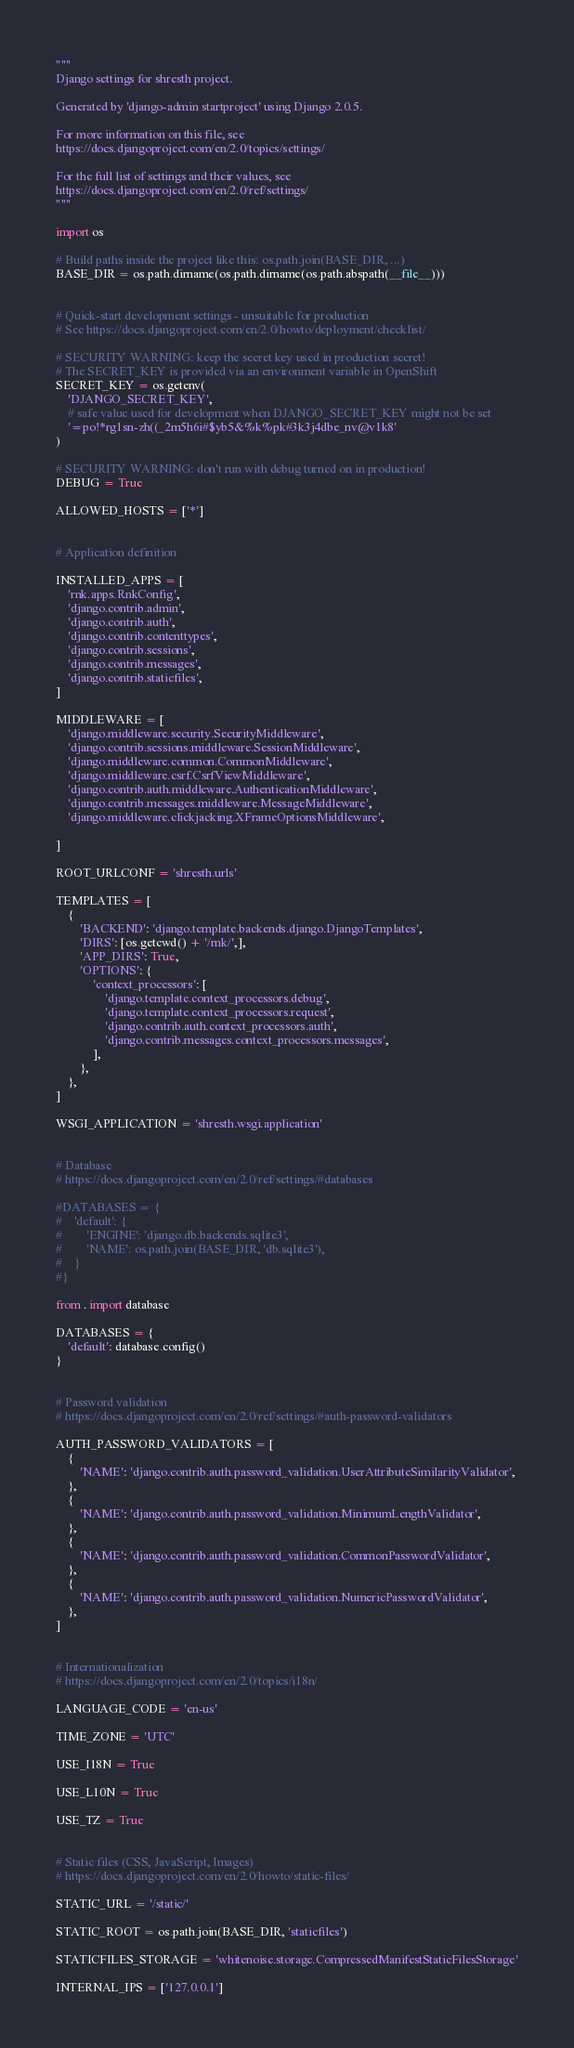Convert code to text. <code><loc_0><loc_0><loc_500><loc_500><_Python_>"""
Django settings for shresth project.

Generated by 'django-admin startproject' using Django 2.0.5.

For more information on this file, see
https://docs.djangoproject.com/en/2.0/topics/settings/

For the full list of settings and their values, see
https://docs.djangoproject.com/en/2.0/ref/settings/
"""

import os

# Build paths inside the project like this: os.path.join(BASE_DIR, ...)
BASE_DIR = os.path.dirname(os.path.dirname(os.path.abspath(__file__)))


# Quick-start development settings - unsuitable for production
# See https://docs.djangoproject.com/en/2.0/howto/deployment/checklist/

# SECURITY WARNING: keep the secret key used in production secret!
# The SECRET_KEY is provided via an environment variable in OpenShift
SECRET_KEY = os.getenv(
    'DJANGO_SECRET_KEY',
    # safe value used for development when DJANGO_SECRET_KEY might not be set
    '=po!*rg1sn-zh((_2m5h6i#$yb5&%k%pk#3k3j4dbe_nv@v1k8'
)

# SECURITY WARNING: don't run with debug turned on in production!
DEBUG = True

ALLOWED_HOSTS = ['*']


# Application definition

INSTALLED_APPS = [
    'rnk.apps.RnkConfig',
    'django.contrib.admin',
    'django.contrib.auth',
    'django.contrib.contenttypes',
    'django.contrib.sessions',
    'django.contrib.messages',
    'django.contrib.staticfiles',
]

MIDDLEWARE = [
    'django.middleware.security.SecurityMiddleware',
    'django.contrib.sessions.middleware.SessionMiddleware',
    'django.middleware.common.CommonMiddleware',
    'django.middleware.csrf.CsrfViewMiddleware',
    'django.contrib.auth.middleware.AuthenticationMiddleware',
    'django.contrib.messages.middleware.MessageMiddleware',
    'django.middleware.clickjacking.XFrameOptionsMiddleware',

]

ROOT_URLCONF = 'shresth.urls'

TEMPLATES = [
    {
        'BACKEND': 'django.template.backends.django.DjangoTemplates',
        'DIRS': [os.getcwd() + '/rnk/',],
        'APP_DIRS': True,
        'OPTIONS': {
            'context_processors': [
                'django.template.context_processors.debug',
                'django.template.context_processors.request',
                'django.contrib.auth.context_processors.auth',
                'django.contrib.messages.context_processors.messages',
            ],
        },
    },
]

WSGI_APPLICATION = 'shresth.wsgi.application'


# Database
# https://docs.djangoproject.com/en/2.0/ref/settings/#databases

#DATABASES = {
#    'default': {
#        'ENGINE': 'django.db.backends.sqlite3',
#        'NAME': os.path.join(BASE_DIR, 'db.sqlite3'),
#    }
#}

from . import database

DATABASES = {
    'default': database.config()
}


# Password validation
# https://docs.djangoproject.com/en/2.0/ref/settings/#auth-password-validators

AUTH_PASSWORD_VALIDATORS = [
    {
        'NAME': 'django.contrib.auth.password_validation.UserAttributeSimilarityValidator',
    },
    {
        'NAME': 'django.contrib.auth.password_validation.MinimumLengthValidator',
    },
    {
        'NAME': 'django.contrib.auth.password_validation.CommonPasswordValidator',
    },
    {
        'NAME': 'django.contrib.auth.password_validation.NumericPasswordValidator',
    },
]


# Internationalization
# https://docs.djangoproject.com/en/2.0/topics/i18n/

LANGUAGE_CODE = 'en-us'

TIME_ZONE = 'UTC'

USE_I18N = True

USE_L10N = True

USE_TZ = True


# Static files (CSS, JavaScript, Images)
# https://docs.djangoproject.com/en/2.0/howto/static-files/

STATIC_URL = '/static/'

STATIC_ROOT = os.path.join(BASE_DIR, 'staticfiles')

STATICFILES_STORAGE = 'whitenoise.storage.CompressedManifestStaticFilesStorage'

INTERNAL_IPS = ['127.0.0.1']
</code> 